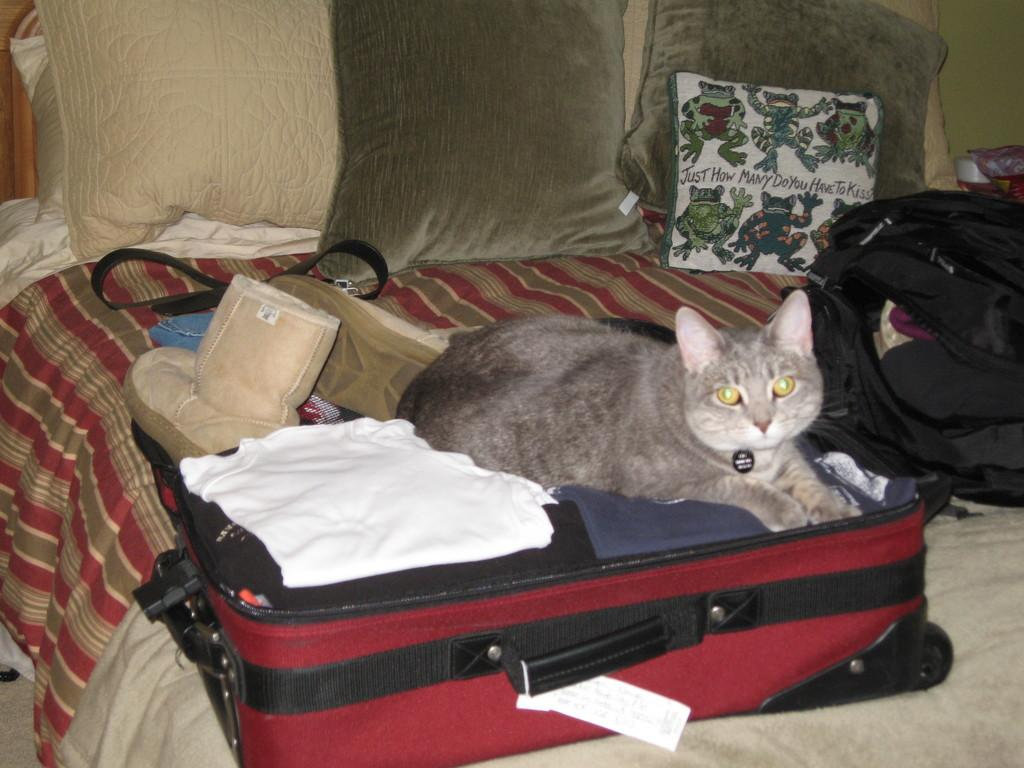What animal can be seen in the image? There is a cat in the image. Where is the cat located in the image? The cat is sitting in a bag. What else is visible in the image besides the cat? There are clothes and a shoe visible in the image. How many pillows are on the bed in the image? There are four pillows on the bed in the image. What type of effect does the cat have on the pizzas in the image? There are no pizzas present in the image, so the cat cannot have any effect on them. 